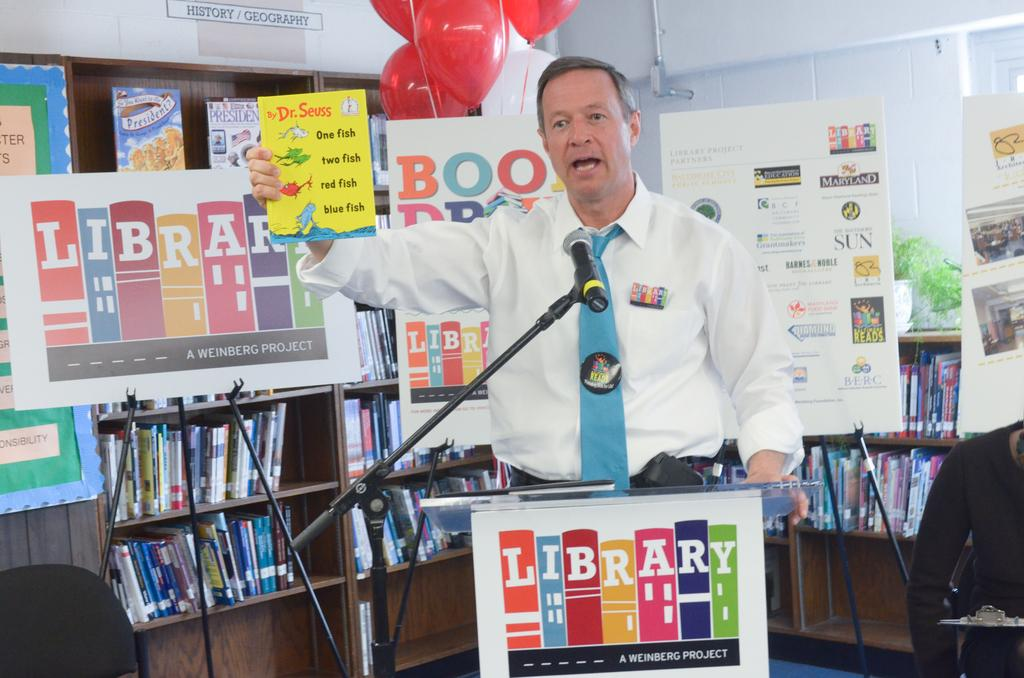<image>
Create a compact narrative representing the image presented. A man giving a speech near a display that says Library while holding a book written by Dr Seuss. 